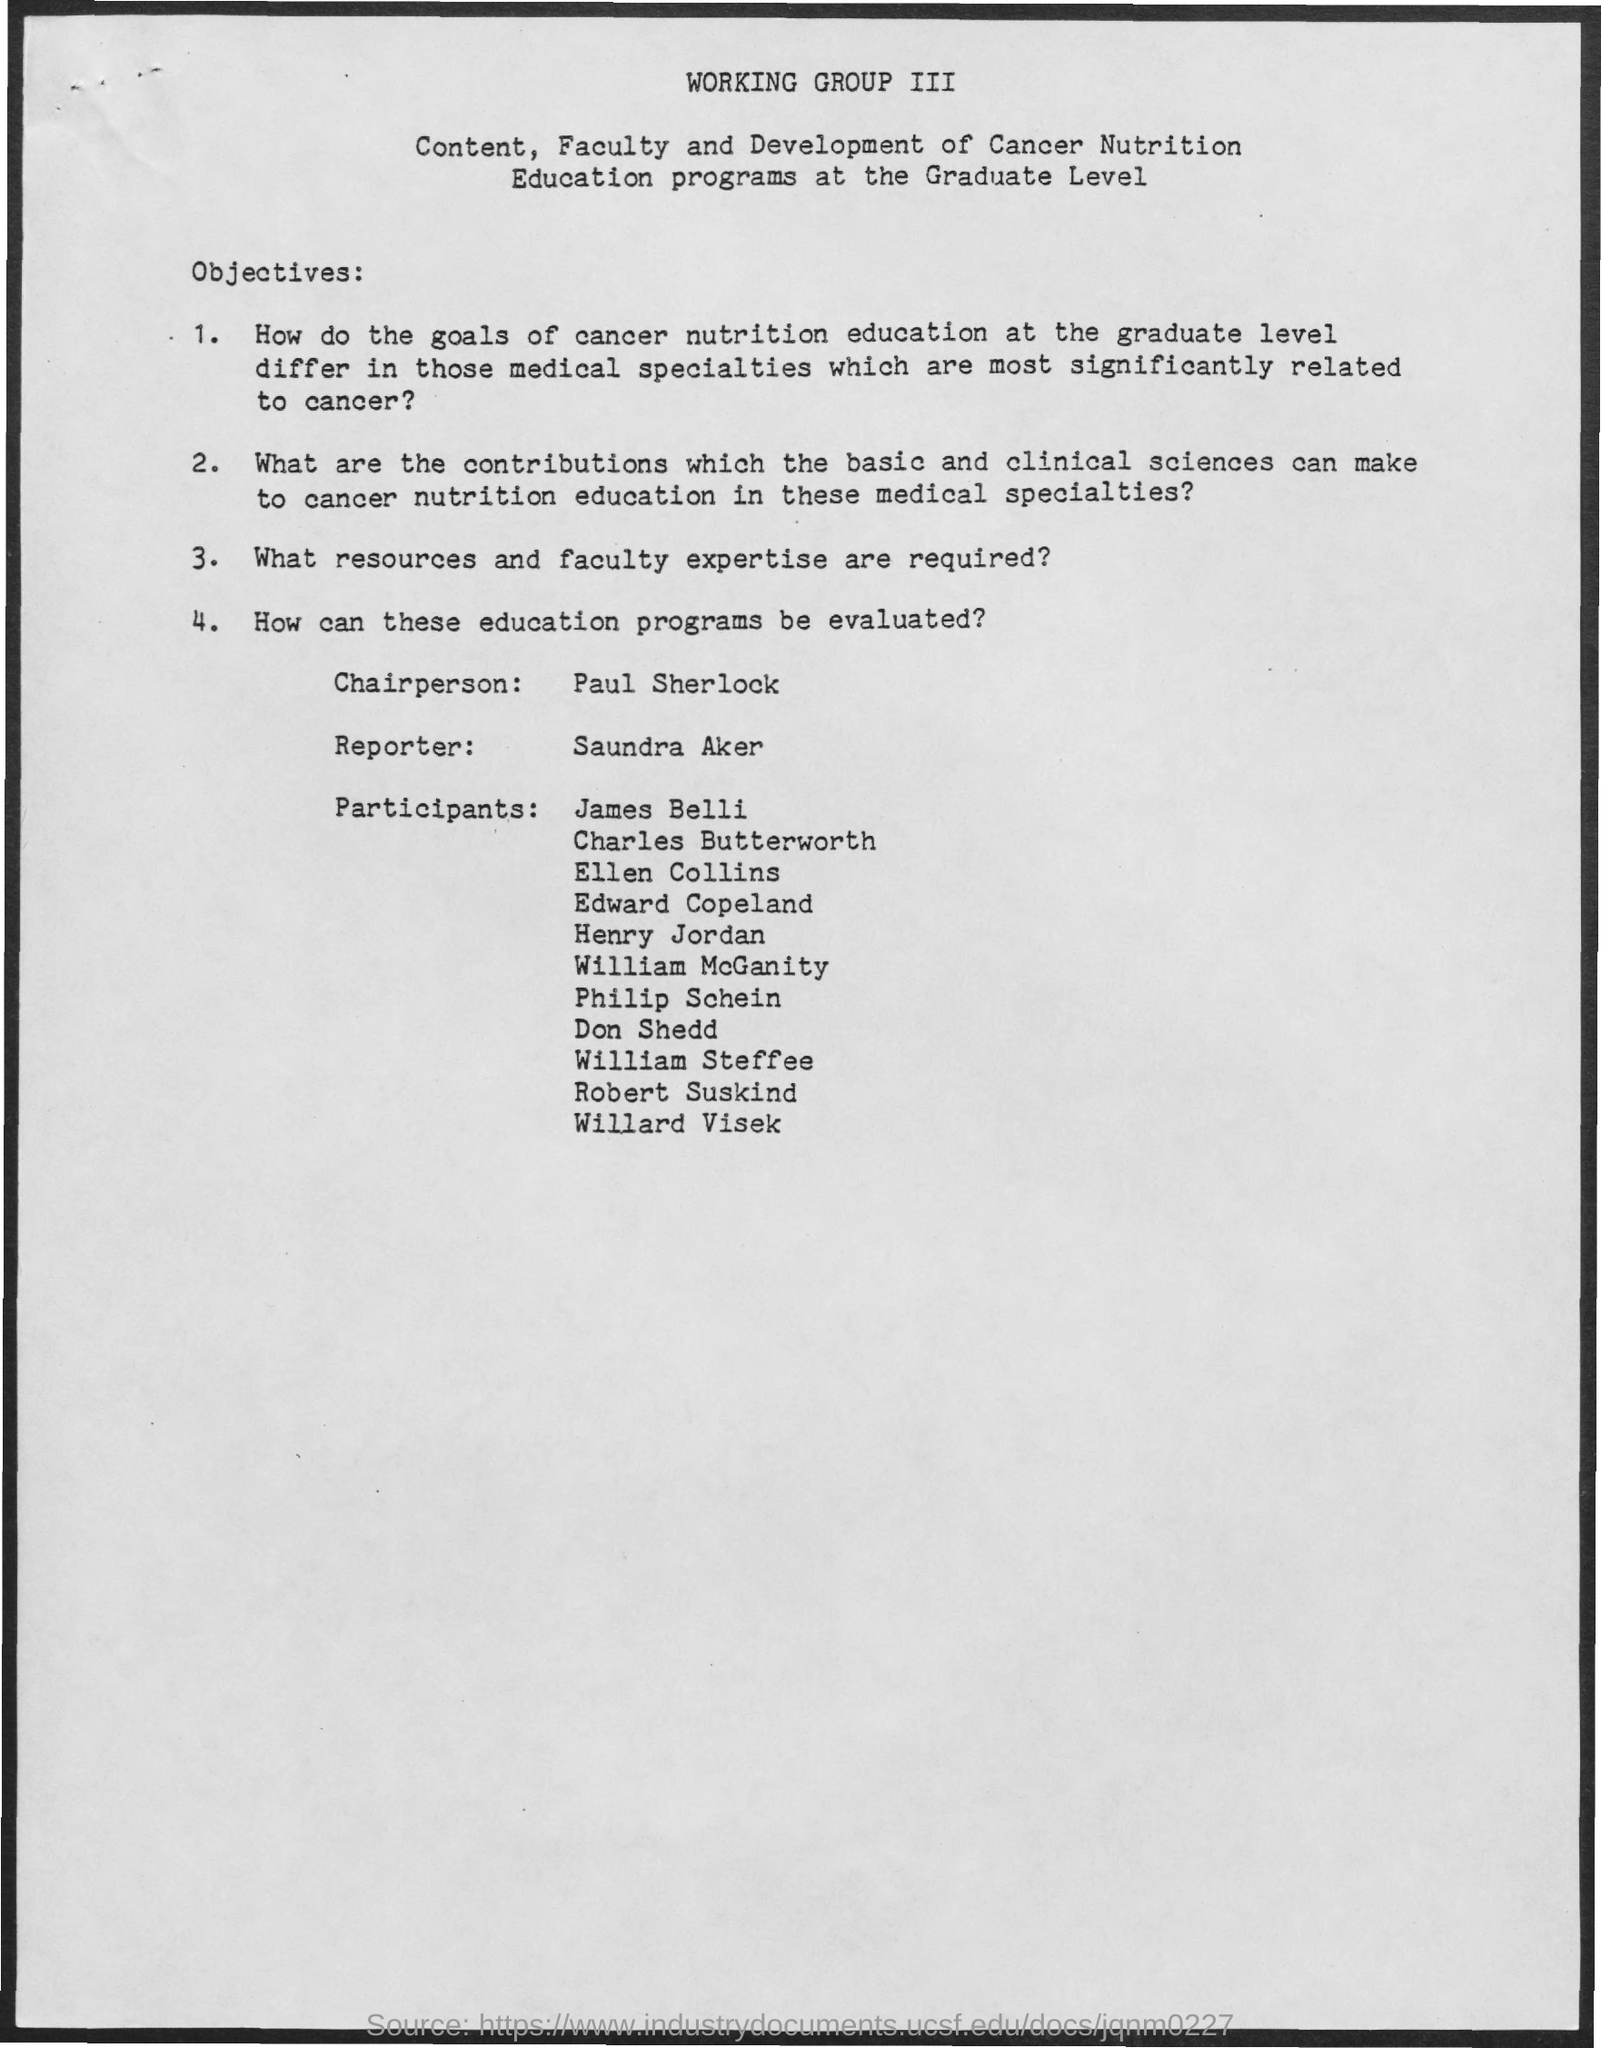Specify some key components in this picture. The reporter named Saundra Aker is mentioned in the given page. The name of the chairperson mentioned in the given page is Paul Sherlock. 